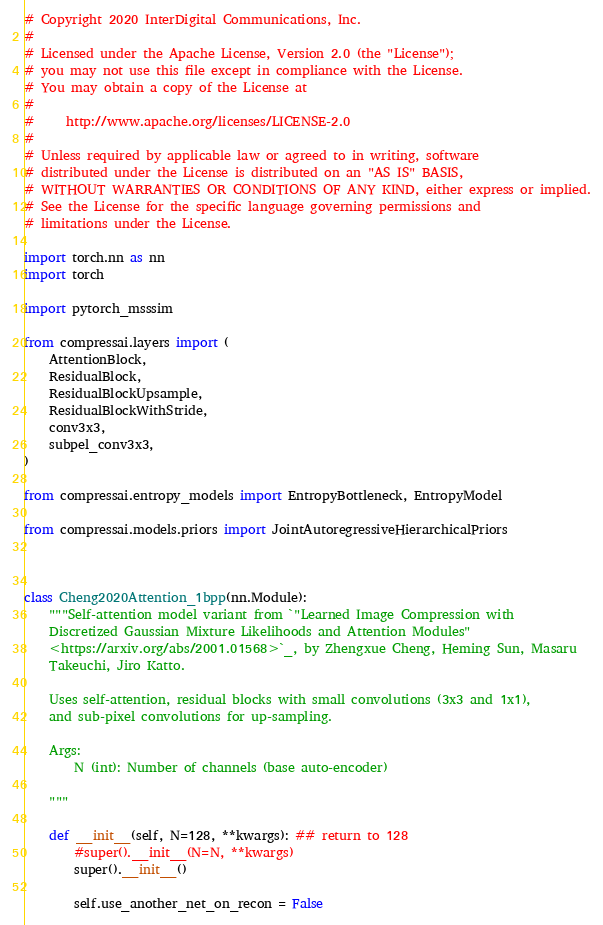<code> <loc_0><loc_0><loc_500><loc_500><_Python_># Copyright 2020 InterDigital Communications, Inc.
#
# Licensed under the Apache License, Version 2.0 (the "License");
# you may not use this file except in compliance with the License.
# You may obtain a copy of the License at
#
#     http://www.apache.org/licenses/LICENSE-2.0
#
# Unless required by applicable law or agreed to in writing, software
# distributed under the License is distributed on an "AS IS" BASIS,
# WITHOUT WARRANTIES OR CONDITIONS OF ANY KIND, either express or implied.
# See the License for the specific language governing permissions and
# limitations under the License.

import torch.nn as nn
import torch

import pytorch_msssim

from compressai.layers import (
    AttentionBlock,
    ResidualBlock,
    ResidualBlockUpsample,
    ResidualBlockWithStride,
    conv3x3,
    subpel_conv3x3,
)

from compressai.entropy_models import EntropyBottleneck, EntropyModel

from compressai.models.priors import JointAutoregressiveHierarchicalPriors



class Cheng2020Attention_1bpp(nn.Module):
    """Self-attention model variant from `"Learned Image Compression with
    Discretized Gaussian Mixture Likelihoods and Attention Modules"
    <https://arxiv.org/abs/2001.01568>`_, by Zhengxue Cheng, Heming Sun, Masaru
    Takeuchi, Jiro Katto.

    Uses self-attention, residual blocks with small convolutions (3x3 and 1x1),
    and sub-pixel convolutions for up-sampling.

    Args:
        N (int): Number of channels (base auto-encoder)

    """

    def __init__(self, N=128, **kwargs): ## return to 128
        #super().__init__(N=N, **kwargs)
        super().__init__()

        self.use_another_net_on_recon = False</code> 